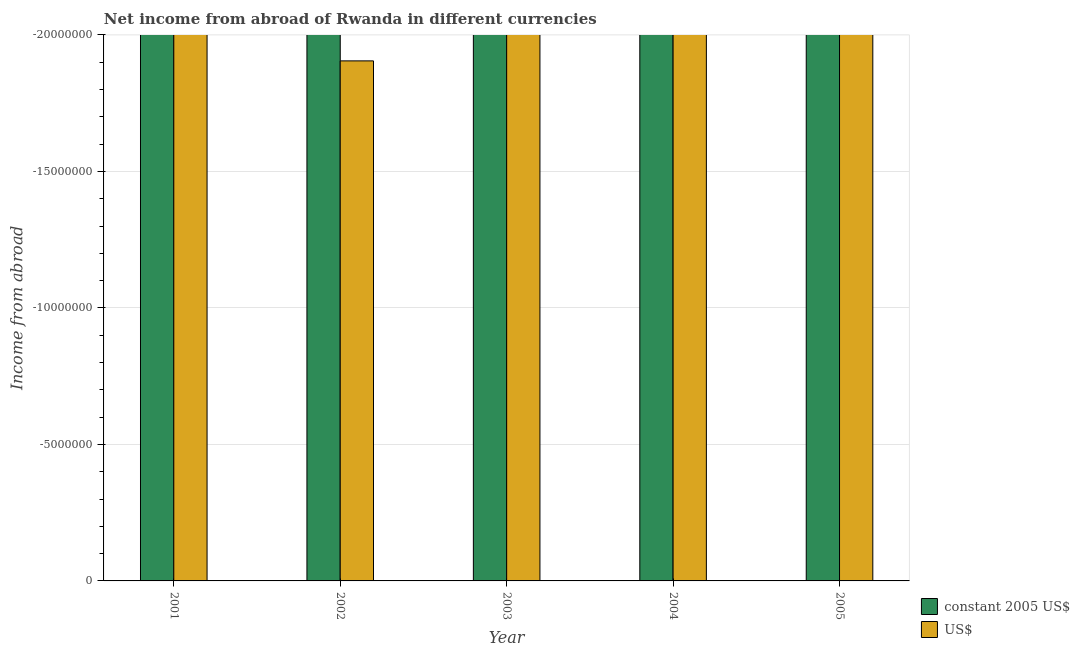How many different coloured bars are there?
Make the answer very short. 0. Are the number of bars on each tick of the X-axis equal?
Offer a terse response. Yes. How many bars are there on the 4th tick from the left?
Ensure brevity in your answer.  0. How many bars are there on the 2nd tick from the right?
Offer a terse response. 0. In how many cases, is the number of bars for a given year not equal to the number of legend labels?
Keep it short and to the point. 5. What is the difference between the income from abroad in us$ in 2003 and the income from abroad in constant 2005 us$ in 2004?
Make the answer very short. 0. What is the average income from abroad in us$ per year?
Your answer should be very brief. 0. In how many years, is the income from abroad in us$ greater than -18000000 units?
Provide a short and direct response. 0. In how many years, is the income from abroad in us$ greater than the average income from abroad in us$ taken over all years?
Your answer should be very brief. 0. How many years are there in the graph?
Provide a succinct answer. 5. What is the difference between two consecutive major ticks on the Y-axis?
Your response must be concise. 5.00e+06. Does the graph contain any zero values?
Make the answer very short. Yes. Where does the legend appear in the graph?
Ensure brevity in your answer.  Bottom right. How many legend labels are there?
Provide a short and direct response. 2. What is the title of the graph?
Provide a succinct answer. Net income from abroad of Rwanda in different currencies. Does "Methane" appear as one of the legend labels in the graph?
Offer a terse response. No. What is the label or title of the X-axis?
Offer a very short reply. Year. What is the label or title of the Y-axis?
Offer a very short reply. Income from abroad. What is the Income from abroad of constant 2005 US$ in 2001?
Provide a short and direct response. 0. What is the Income from abroad in US$ in 2002?
Offer a terse response. 0. What is the Income from abroad in constant 2005 US$ in 2004?
Provide a succinct answer. 0. What is the Income from abroad in constant 2005 US$ in 2005?
Give a very brief answer. 0. What is the total Income from abroad of constant 2005 US$ in the graph?
Your answer should be very brief. 0. What is the total Income from abroad of US$ in the graph?
Your response must be concise. 0. What is the average Income from abroad in constant 2005 US$ per year?
Your answer should be compact. 0. What is the average Income from abroad of US$ per year?
Your answer should be very brief. 0. 